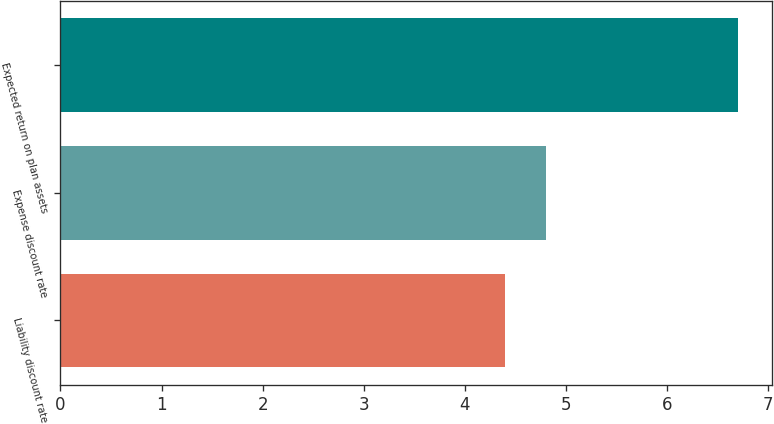<chart> <loc_0><loc_0><loc_500><loc_500><bar_chart><fcel>Liability discount rate<fcel>Expense discount rate<fcel>Expected return on plan assets<nl><fcel>4.4<fcel>4.8<fcel>6.7<nl></chart> 